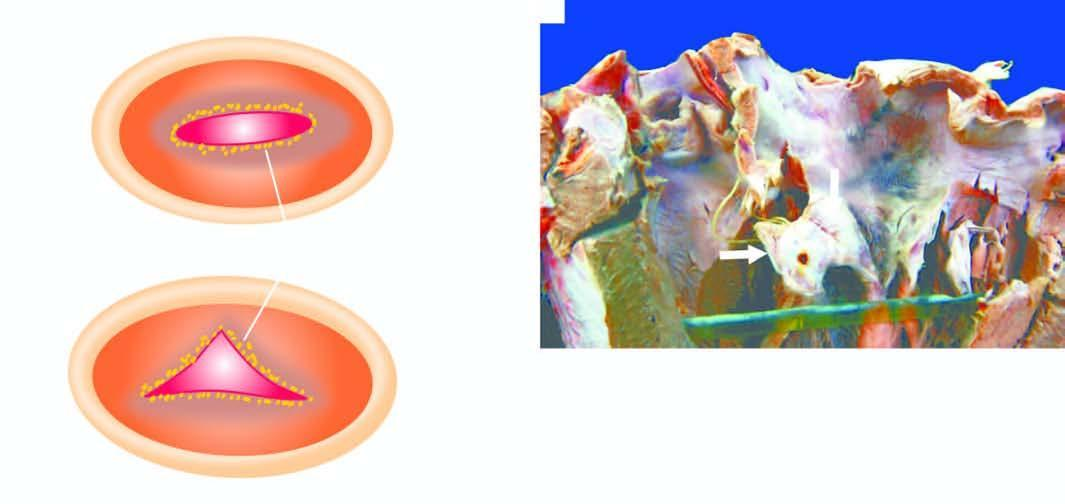what are shown as seen from the left ventricular surface?
Answer the question using a single word or phrase. Vegetations on aortic valve 